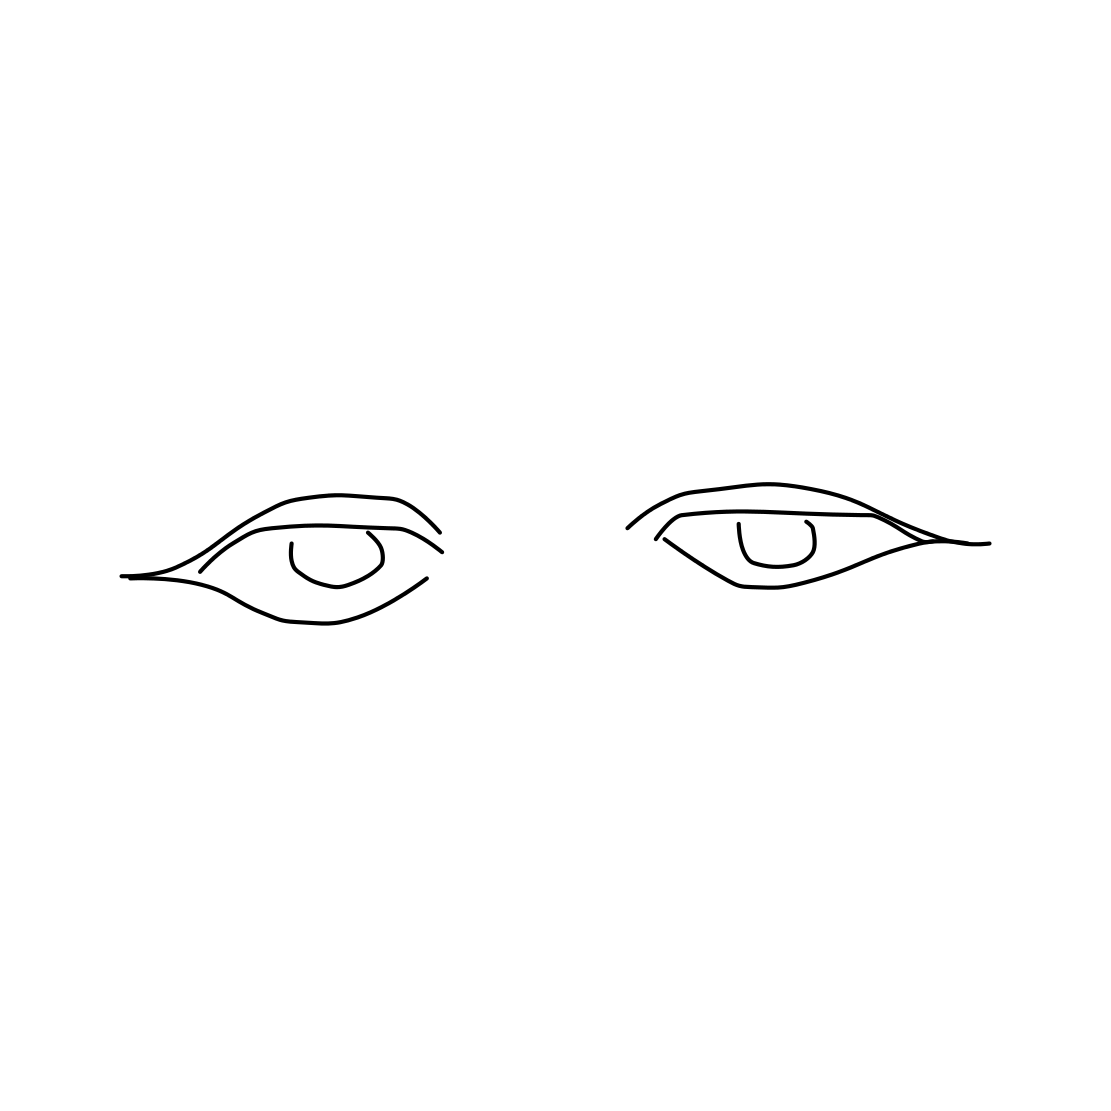Is there a sketchy eye in the picture? Absolutely, the picture features a sketched representation of a pair of eyes, outlined in a simple yet expressive style. The eyes have distinct upper and lower eyelids, along with pupils, showcasing the basic elements of eye sketching. 